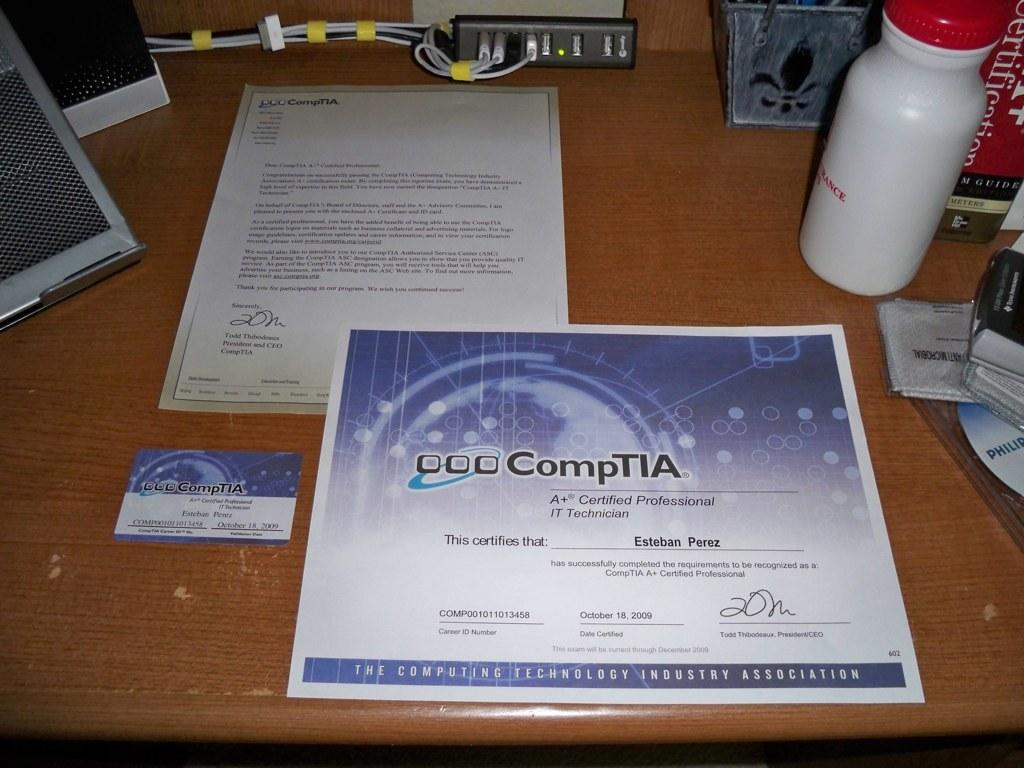<image>
Write a terse but informative summary of the picture. A certificate from CompTIA sits on a cluttered desk 